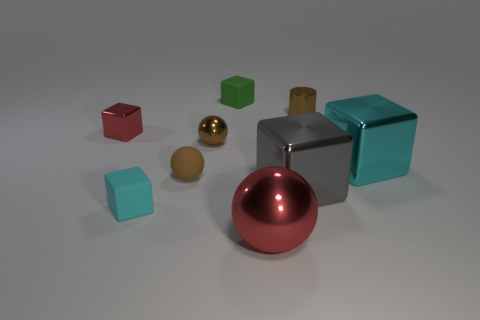What size is the red metallic object that is behind the big red thing?
Keep it short and to the point. Small. What number of shiny cubes are on the right side of the small green rubber cube that is on the right side of the brown shiny object in front of the tiny cylinder?
Keep it short and to the point. 2. Are there any green things behind the metal cylinder?
Provide a succinct answer. Yes. What number of other objects are there of the same size as the brown metallic cylinder?
Your answer should be very brief. 5. There is a thing that is both right of the big gray object and behind the tiny red object; what material is it?
Ensure brevity in your answer.  Metal. Does the cyan object right of the small brown matte thing have the same shape as the small brown thing that is in front of the cyan metallic cube?
Provide a succinct answer. No. Is there any other thing that is the same material as the small cyan object?
Your response must be concise. Yes. The tiny metallic object in front of the metal cube that is behind the tiny brown metallic object that is left of the big metal sphere is what shape?
Offer a very short reply. Sphere. What number of other objects are there of the same shape as the gray thing?
Your answer should be very brief. 4. The other cube that is the same size as the gray block is what color?
Ensure brevity in your answer.  Cyan. 